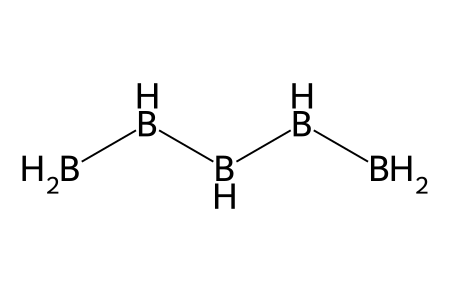what is the name of the chemical represented by this structure? The SMILES representation shows a structure comprising five boron (B) atoms and ten hydrogen (H) atoms, corresponding to the compound pentaborane.
Answer: pentaborane how many hydrogen atoms are there in this molecule? Analyzing the SMILES representation, there are five boron atoms and ten hydrogen atoms linked, indicating the number of hydrogen atoms in the molecule.
Answer: 10 what is the hybridization of the boron atoms in pentaborane? Each boron atom in pentaborane exhibits sp3 hybridization due to the presence of four substituents (three hydrogen atoms and one boron atom) forming a tetrahedral arrangement.
Answer: sp3 how many main structural units does pentaborane contain? The visualization of the SMILES structure shows that there are five boron atoms linked through boron-hydrogen bond connections, which counts as the main structural units.
Answer: 5 what type of bonding primarily exists in pentaborane? The presence of boron and hydrogen atoms linked predominantly through single covalent bonds indicates that pentaborane primarily exhibits covalent bonding.
Answer: covalent what is the molecular geometry of pentaborane? By considering the arrangement of the five boron atoms and hydrogen around them, along with the sp3 hybridization, it's evident that pentaborane exhibits a complex molecular geometry that is non-polar and results in a unique structure.
Answer: non-planar how does the bonding in pentaborane compare to traditional hydrocarbons? In pentaborane, the presence of boron atoms creates a unique multi-boron bonding scenario compared to traditional hydrocarbons, which consist primarily of carbon and hydrogen, leading to distinctive properties and geometries compared to alkanes.
Answer: unique bonding 